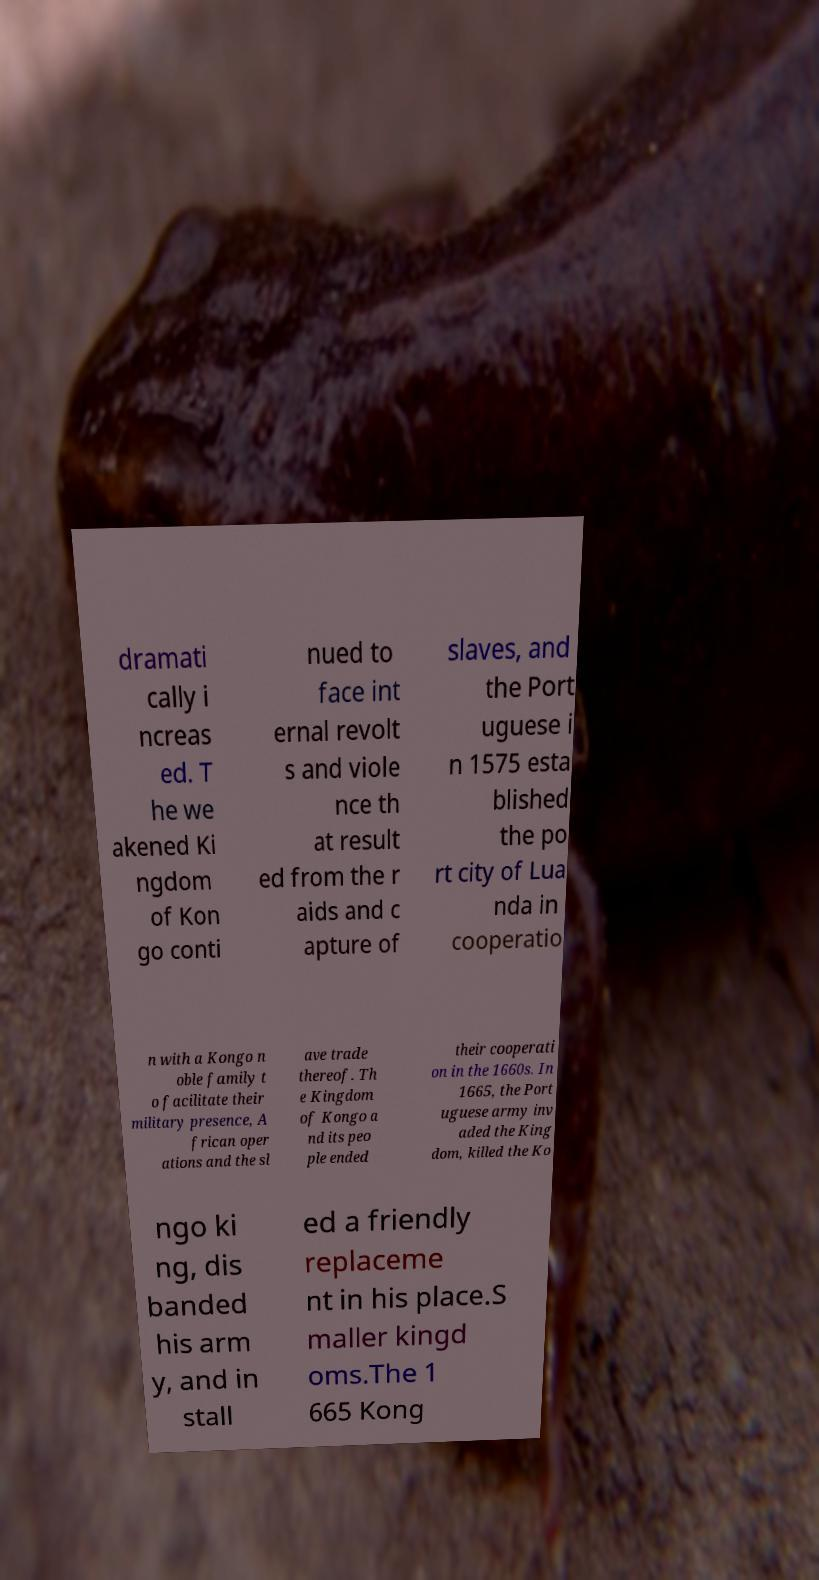What messages or text are displayed in this image? I need them in a readable, typed format. dramati cally i ncreas ed. T he we akened Ki ngdom of Kon go conti nued to face int ernal revolt s and viole nce th at result ed from the r aids and c apture of slaves, and the Port uguese i n 1575 esta blished the po rt city of Lua nda in cooperatio n with a Kongo n oble family t o facilitate their military presence, A frican oper ations and the sl ave trade thereof. Th e Kingdom of Kongo a nd its peo ple ended their cooperati on in the 1660s. In 1665, the Port uguese army inv aded the King dom, killed the Ko ngo ki ng, dis banded his arm y, and in stall ed a friendly replaceme nt in his place.S maller kingd oms.The 1 665 Kong 